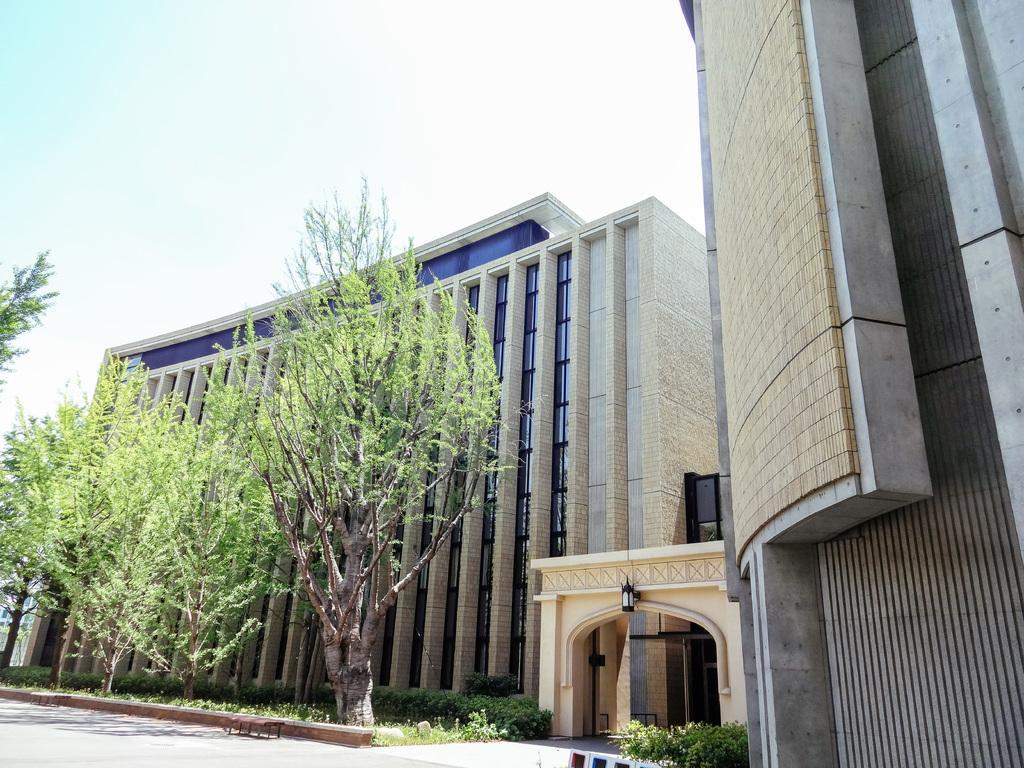Please provide a concise description of this image. In the picture we can see some buildings near to it, we can see some plants on the path and some trees and a gateway to the building and behind the building we can see a sky. 